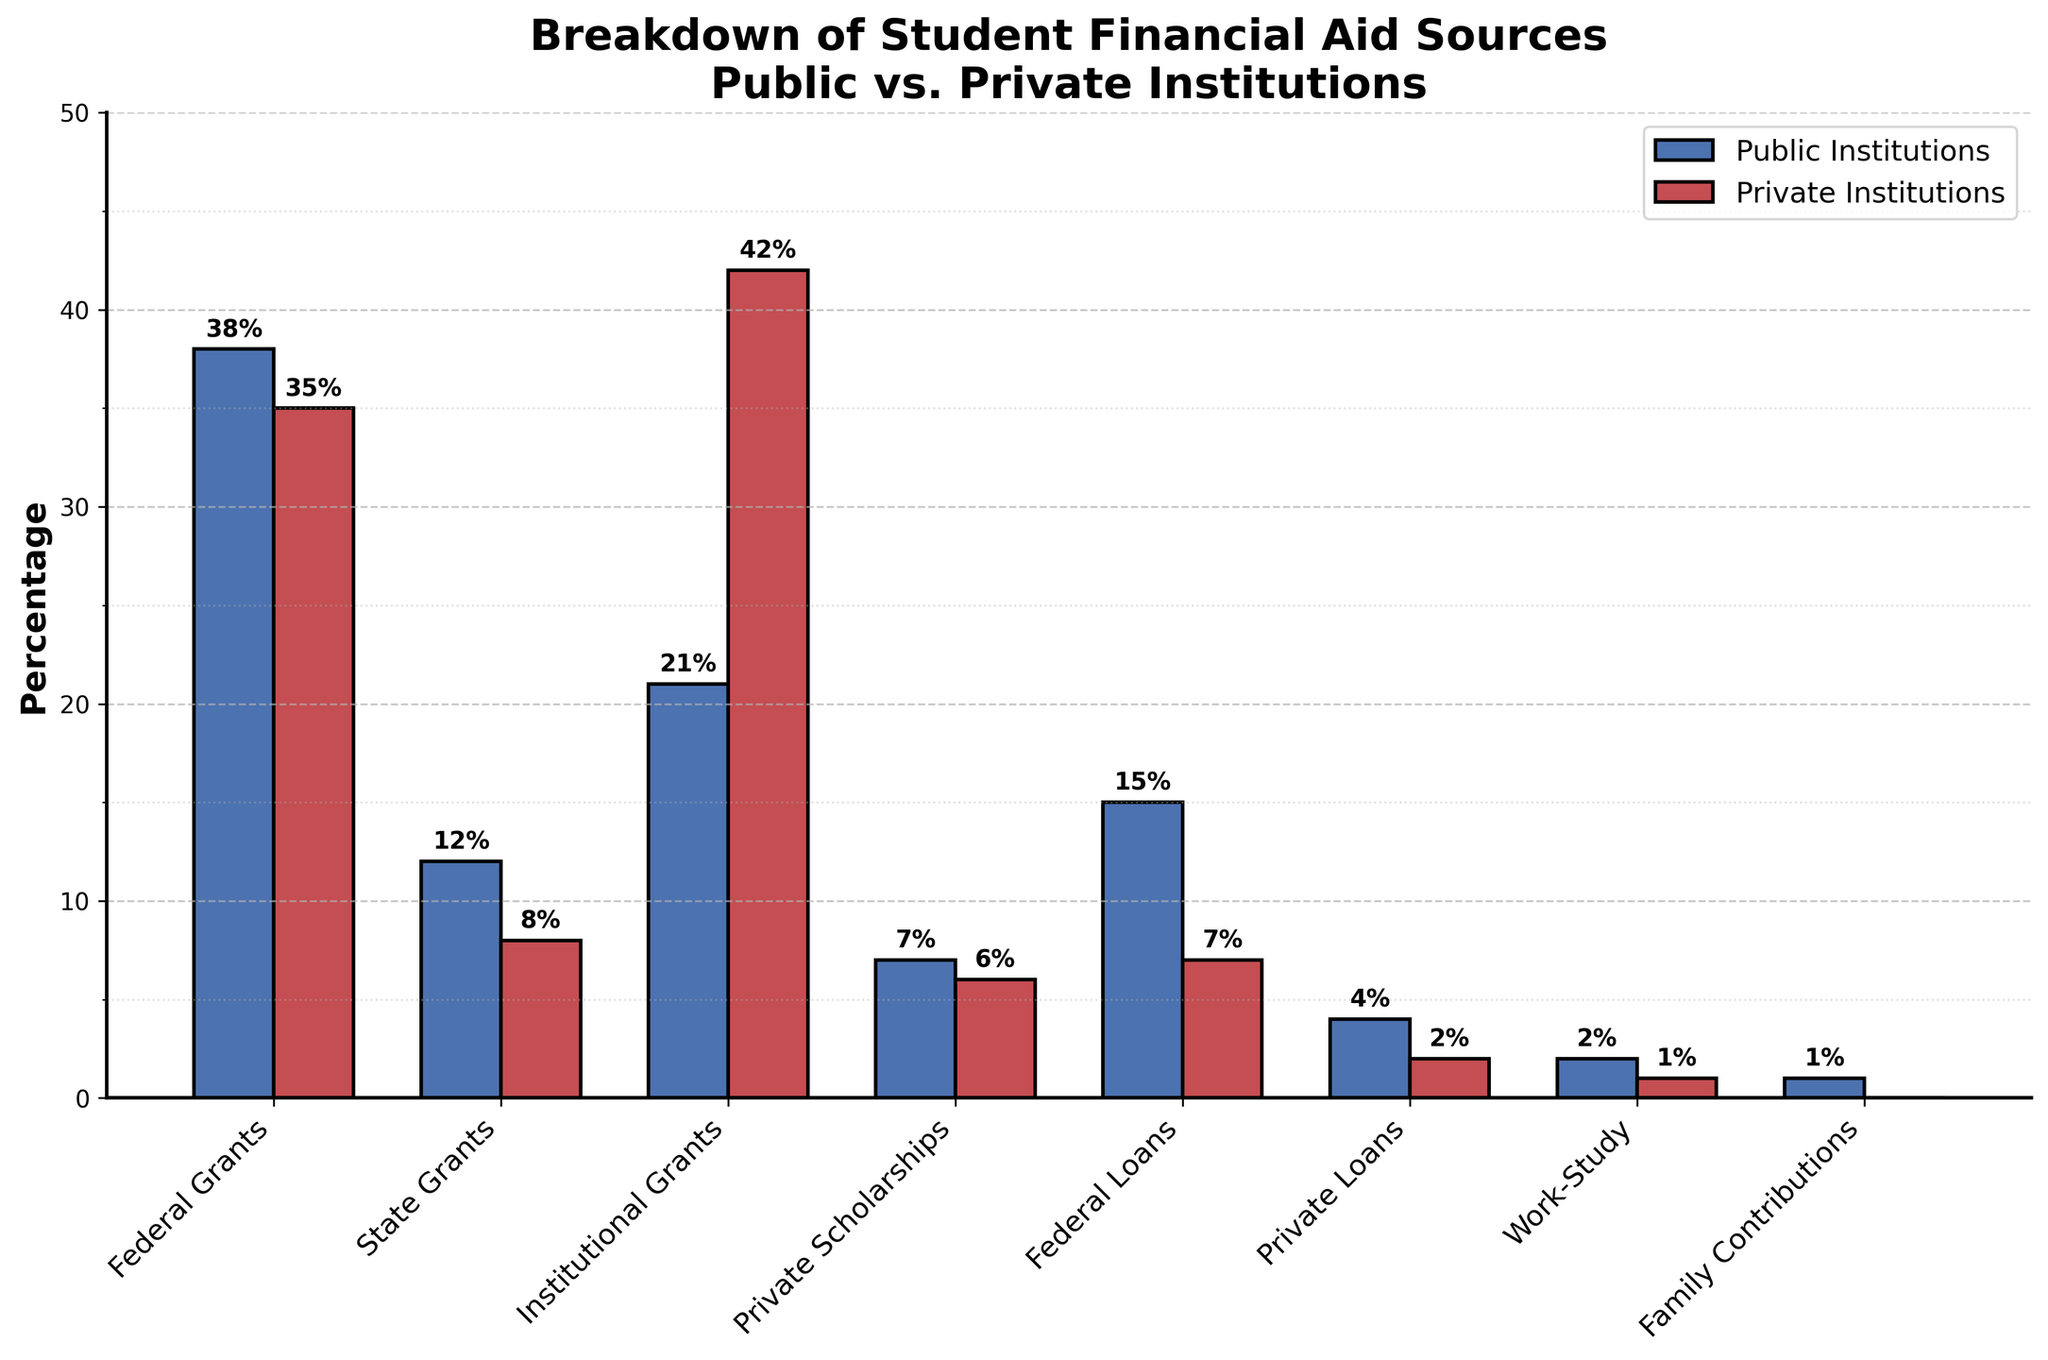Which financial aid source has the largest difference in percentage between public and private institutions? Look at each financial aid source and compute the absolute difference between percentages for public and private institutions. The largest difference is for Institutional Grants (42% - 21% = 21%).
Answer: Institutional Grants What is the total percentage of financial aid coming from federal sources (grants and loans) for public institutions? Sum the percentages of Federal Grants and Federal Loans for public institutions. It is 38% (Federal Grants) + 15% (Federal Loans) = 53%.
Answer: 53% Which type of financial aid has the smallest percentage for public institutions? Identify the smallest bar within the public institutions group. The smallest percentage is for Family Contributions at 1%.
Answer: Family Contributions Between state grants and institutional grants, which has a higher percentage in private institutions? Compare the heights of the bars for State Grants and Institutional Grants in private institutions. Institutional Grants, with a percentage of 42%, is higher than State Grants at 8%.
Answer: Institutional Grants How do federal loans compare between public and private institutions? Compare the heights of the bars for Federal Loans in public and private institutions. Public institutions have a higher percentage (15%) compared to private institutions (7%).
Answer: Public institutions have a higher percentage What is the combined percentage of financial aid from institutional and private sources (grants and scholarships) for private institutions? Add the percentages for Institutional Grants and Private Scholarships in private institutions: 42% + 6% = 48%.
Answer: 48% For which type of financial aid is the percentage almost equal between public and private institutions? Identify the financial aid sources where the bars for public and private institutions have similar heights. Federal Grants have percentages of 38% for public and 35% for private, showing a small difference.
Answer: Federal Grants What percentage of work-study financial aid is provided by private institutions? Look at the height of the bar for Work-Study financial aid in private institutions. The percentage is 1%.
Answer: 1% Which institution type relies more on state grants? Compare the heights of the bars for State Grants between public and private institutions. Public institutions have a higher percentage (12%) compared to private institutions (8%).
Answer: Public institutions How much higher is the percentage of institutional grants in private institutions compared to public institutions? Calculate the difference in percentage for Institutional Grants between private and public institutions. The difference is 42% (private) - 21% (public) = 21%.
Answer: 21% 